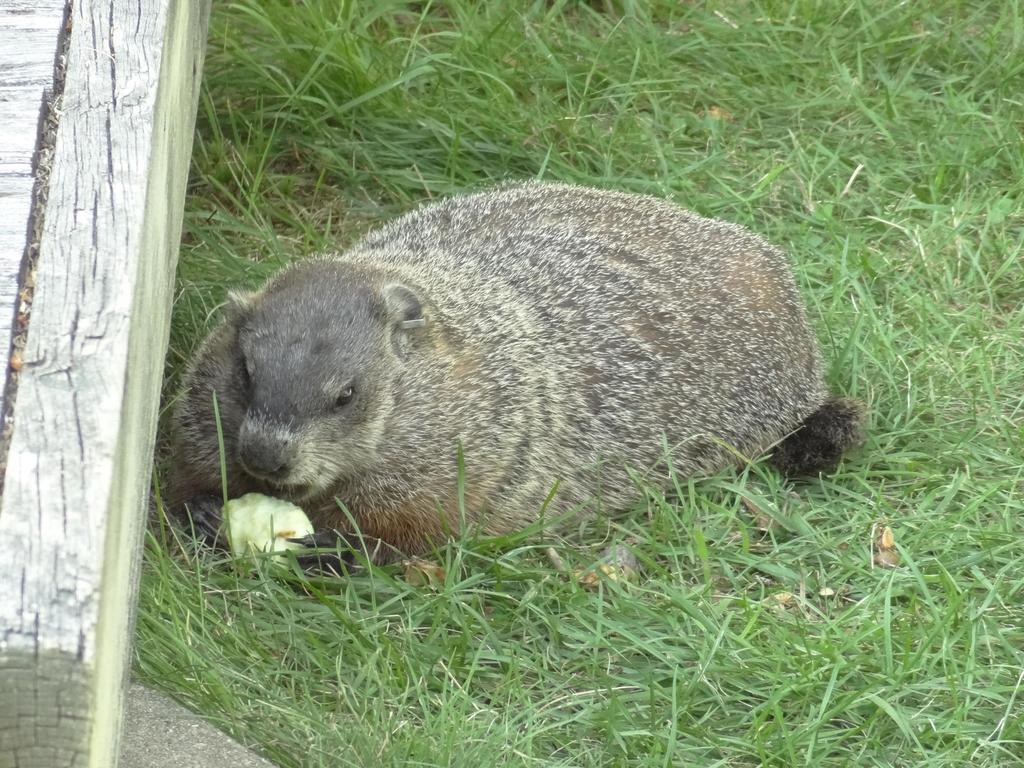What type of creature is in the image? There is an animal in the image. What is the animal doing in the image? The animal is holding food. Can you describe the object on the left side of the image? There is a wooden object on the left side of the image. What type of natural environment is visible in the image? Grass is present at the bottom of the image. What type of skirt is the animal wearing in the image? There is no skirt present in the image; the animal is not wearing any clothing. 